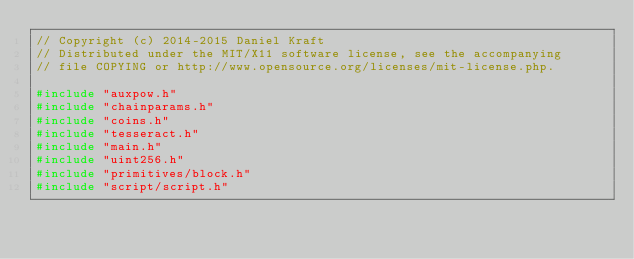Convert code to text. <code><loc_0><loc_0><loc_500><loc_500><_C++_>// Copyright (c) 2014-2015 Daniel Kraft
// Distributed under the MIT/X11 software license, see the accompanying
// file COPYING or http://www.opensource.org/licenses/mit-license.php.

#include "auxpow.h"
#include "chainparams.h"
#include "coins.h"
#include "tesseract.h"
#include "main.h"
#include "uint256.h"
#include "primitives/block.h"
#include "script/script.h"
</code> 